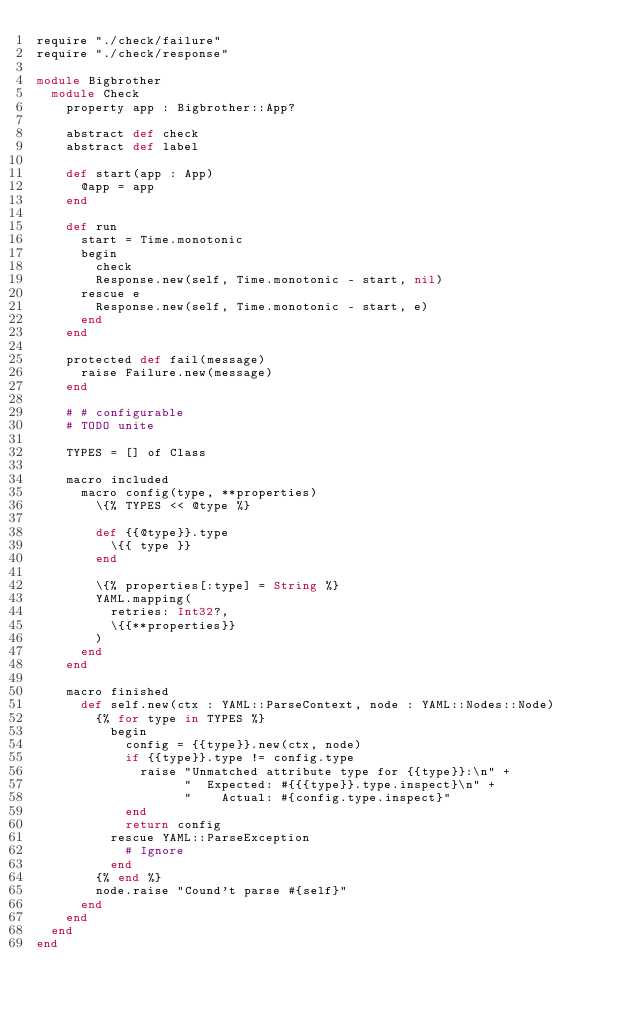<code> <loc_0><loc_0><loc_500><loc_500><_Crystal_>require "./check/failure"
require "./check/response"

module Bigbrother
  module Check
    property app : Bigbrother::App?

    abstract def check
    abstract def label

    def start(app : App)
      @app = app
    end

    def run
      start = Time.monotonic
      begin
        check
        Response.new(self, Time.monotonic - start, nil)
      rescue e
        Response.new(self, Time.monotonic - start, e)
      end
    end

    protected def fail(message)
      raise Failure.new(message)
    end

    # # configurable
    # TODO unite

    TYPES = [] of Class

    macro included
      macro config(type, **properties)
        \{% TYPES << @type %}

        def {{@type}}.type
          \{{ type }}
        end

        \{% properties[:type] = String %}
        YAML.mapping(
          retries: Int32?,
          \{{**properties}}
        )
      end
    end

    macro finished
      def self.new(ctx : YAML::ParseContext, node : YAML::Nodes::Node)
        {% for type in TYPES %}
          begin
            config = {{type}}.new(ctx, node)
            if {{type}}.type != config.type
              raise "Unmatched attribute type for {{type}}:\n" +
                    "  Expected: #{{{type}}.type.inspect}\n" +
                    "    Actual: #{config.type.inspect}"
            end
            return config
          rescue YAML::ParseException
            # Ignore
          end
        {% end %}
        node.raise "Cound't parse #{self}"
      end
    end
  end
end
</code> 